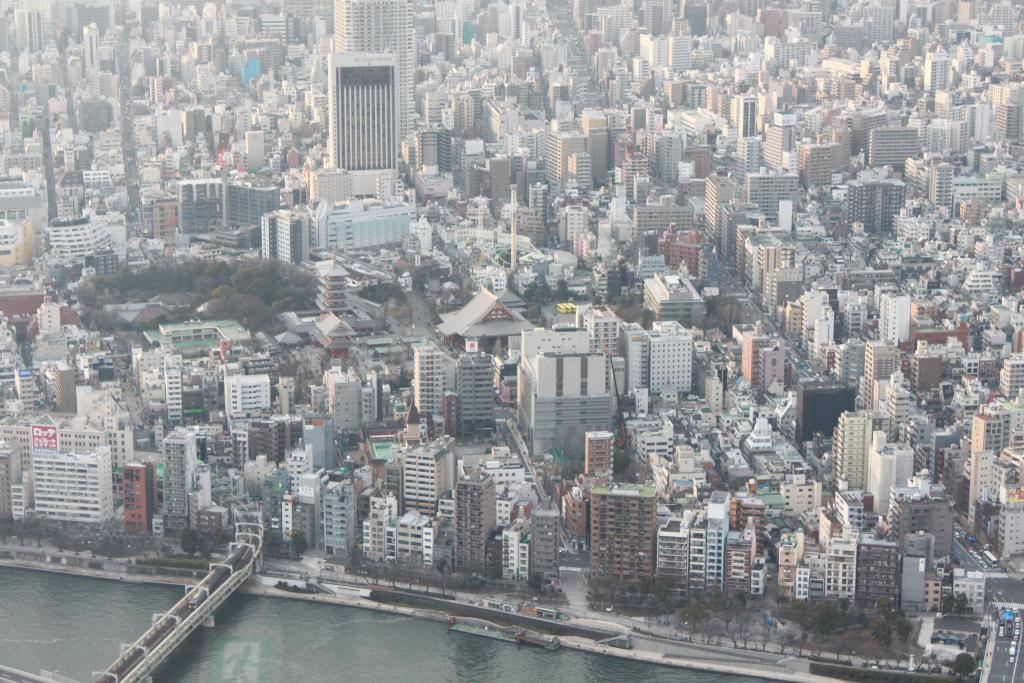What type of structures can be seen in the image? There are many buildings in the image. What natural elements are present in the image? There are trees in the image. What body of water is visible in the image? There is a canal at the bottom of the image. What architectural feature connects the two sides of the canal? There is a bridge in the image. What type of nerve can be seen running through the canal in the image? There are no nerves present in the image; it features buildings, trees, a canal, and a bridge. What type of territory is depicted in the image? The image does not depict a specific territory; it shows a general urban landscape with buildings, trees, a canal, and a bridge. 